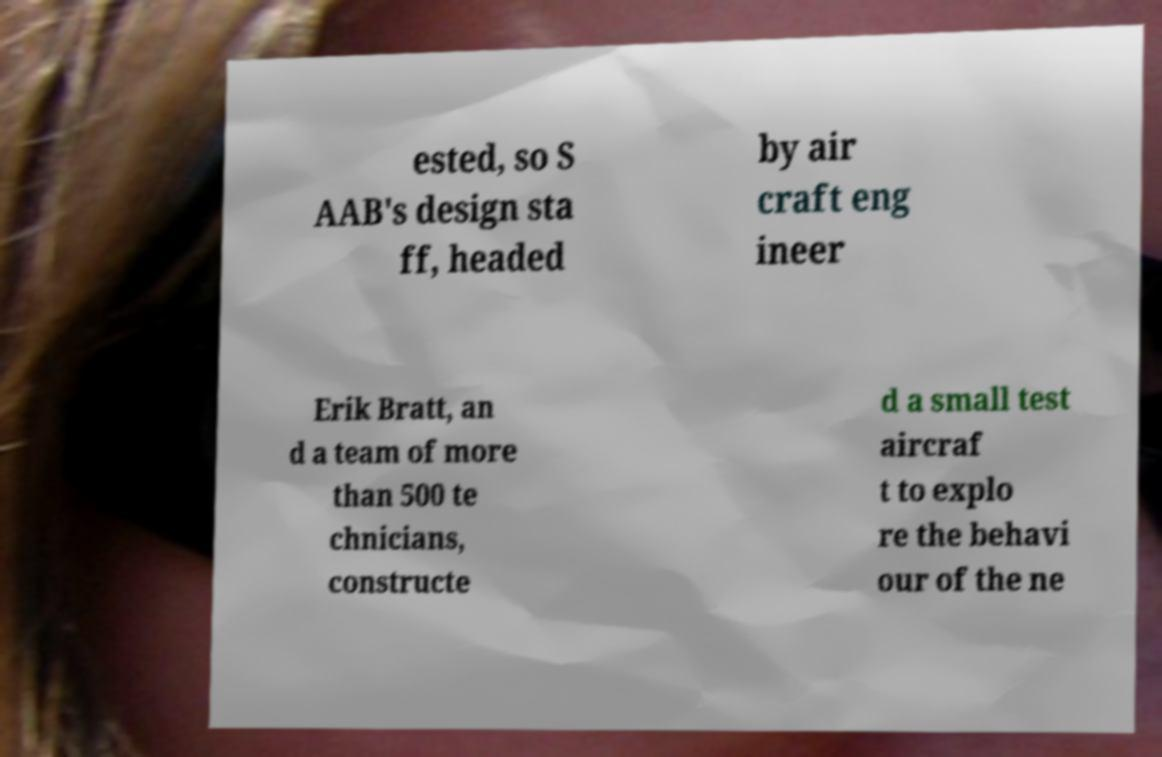Please identify and transcribe the text found in this image. ested, so S AAB's design sta ff, headed by air craft eng ineer Erik Bratt, an d a team of more than 500 te chnicians, constructe d a small test aircraf t to explo re the behavi our of the ne 